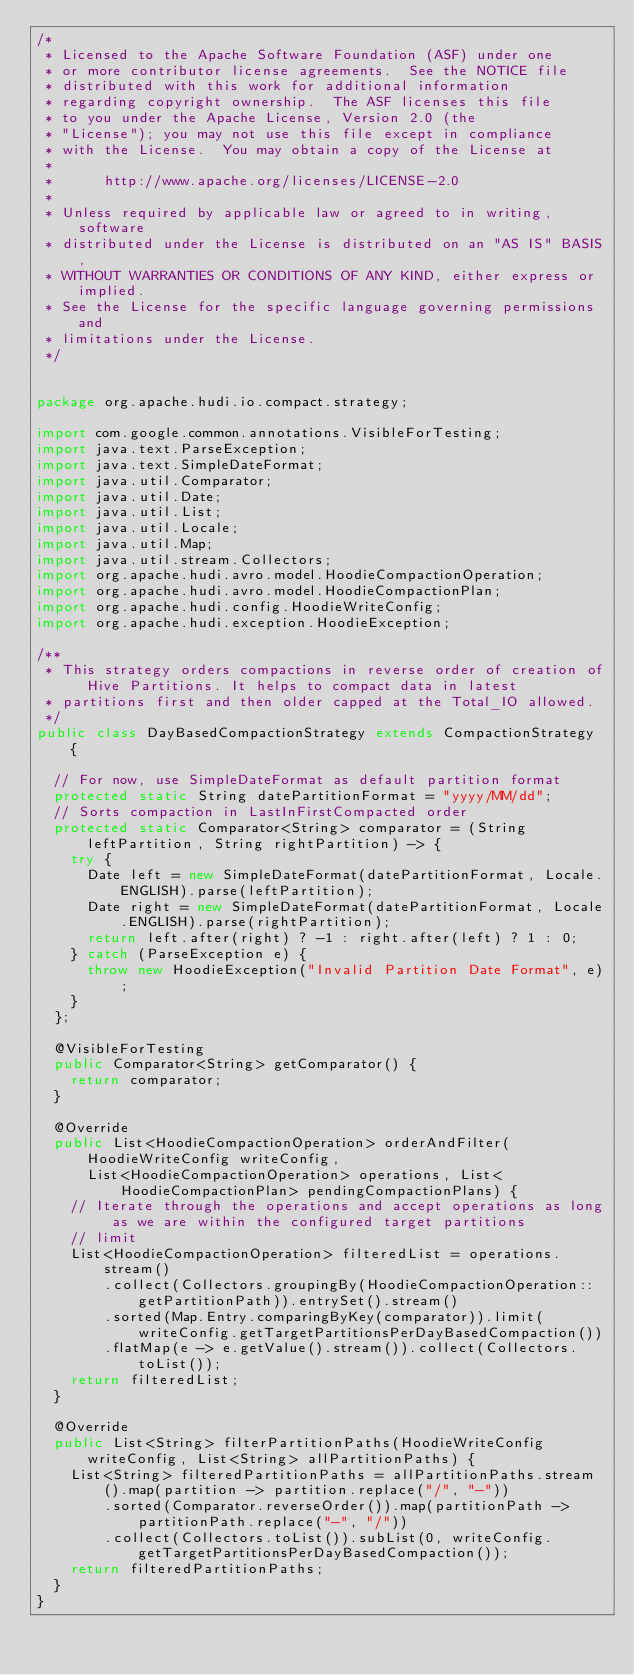<code> <loc_0><loc_0><loc_500><loc_500><_Java_>/*
 * Licensed to the Apache Software Foundation (ASF) under one
 * or more contributor license agreements.  See the NOTICE file
 * distributed with this work for additional information
 * regarding copyright ownership.  The ASF licenses this file
 * to you under the Apache License, Version 2.0 (the
 * "License"); you may not use this file except in compliance
 * with the License.  You may obtain a copy of the License at
 *
 *      http://www.apache.org/licenses/LICENSE-2.0
 *
 * Unless required by applicable law or agreed to in writing, software
 * distributed under the License is distributed on an "AS IS" BASIS,
 * WITHOUT WARRANTIES OR CONDITIONS OF ANY KIND, either express or implied.
 * See the License for the specific language governing permissions and
 * limitations under the License.
 */


package org.apache.hudi.io.compact.strategy;

import com.google.common.annotations.VisibleForTesting;
import java.text.ParseException;
import java.text.SimpleDateFormat;
import java.util.Comparator;
import java.util.Date;
import java.util.List;
import java.util.Locale;
import java.util.Map;
import java.util.stream.Collectors;
import org.apache.hudi.avro.model.HoodieCompactionOperation;
import org.apache.hudi.avro.model.HoodieCompactionPlan;
import org.apache.hudi.config.HoodieWriteConfig;
import org.apache.hudi.exception.HoodieException;

/**
 * This strategy orders compactions in reverse order of creation of Hive Partitions. It helps to compact data in latest
 * partitions first and then older capped at the Total_IO allowed.
 */
public class DayBasedCompactionStrategy extends CompactionStrategy {

  // For now, use SimpleDateFormat as default partition format
  protected static String datePartitionFormat = "yyyy/MM/dd";
  // Sorts compaction in LastInFirstCompacted order
  protected static Comparator<String> comparator = (String leftPartition, String rightPartition) -> {
    try {
      Date left = new SimpleDateFormat(datePartitionFormat, Locale.ENGLISH).parse(leftPartition);
      Date right = new SimpleDateFormat(datePartitionFormat, Locale.ENGLISH).parse(rightPartition);
      return left.after(right) ? -1 : right.after(left) ? 1 : 0;
    } catch (ParseException e) {
      throw new HoodieException("Invalid Partition Date Format", e);
    }
  };

  @VisibleForTesting
  public Comparator<String> getComparator() {
    return comparator;
  }

  @Override
  public List<HoodieCompactionOperation> orderAndFilter(HoodieWriteConfig writeConfig,
      List<HoodieCompactionOperation> operations, List<HoodieCompactionPlan> pendingCompactionPlans) {
    // Iterate through the operations and accept operations as long as we are within the configured target partitions
    // limit
    List<HoodieCompactionOperation> filteredList = operations.stream()
        .collect(Collectors.groupingBy(HoodieCompactionOperation::getPartitionPath)).entrySet().stream()
        .sorted(Map.Entry.comparingByKey(comparator)).limit(writeConfig.getTargetPartitionsPerDayBasedCompaction())
        .flatMap(e -> e.getValue().stream()).collect(Collectors.toList());
    return filteredList;
  }

  @Override
  public List<String> filterPartitionPaths(HoodieWriteConfig writeConfig, List<String> allPartitionPaths) {
    List<String> filteredPartitionPaths = allPartitionPaths.stream().map(partition -> partition.replace("/", "-"))
        .sorted(Comparator.reverseOrder()).map(partitionPath -> partitionPath.replace("-", "/"))
        .collect(Collectors.toList()).subList(0, writeConfig.getTargetPartitionsPerDayBasedCompaction());
    return filteredPartitionPaths;
  }
}
</code> 